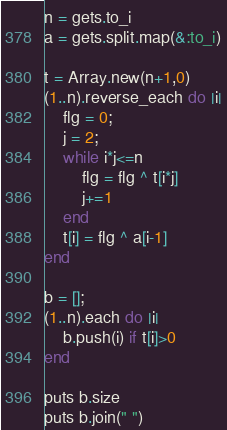<code> <loc_0><loc_0><loc_500><loc_500><_Ruby_>n = gets.to_i
a = gets.split.map(&:to_i)

t = Array.new(n+1,0)
(1..n).reverse_each do |i|
    flg = 0;
    j = 2;
    while i*j<=n
        flg = flg ^ t[i*j]
        j+=1
    end
    t[i] = flg ^ a[i-1]
end

b = [];
(1..n).each do |i|
    b.push(i) if t[i]>0
end

puts b.size
puts b.join(" ")
</code> 